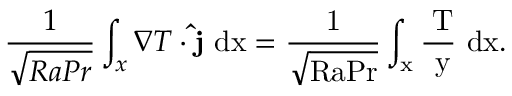Convert formula to latex. <formula><loc_0><loc_0><loc_500><loc_500>\frac { 1 } { \sqrt { R a P r } } \int _ { x } \nabla T \cdot \hat { j } \ { d } x = \frac { 1 } { \sqrt { R a P r } } \int _ { x } \frac { \partial T } { \partial y } \ \mathrm { { d } x . }</formula> 